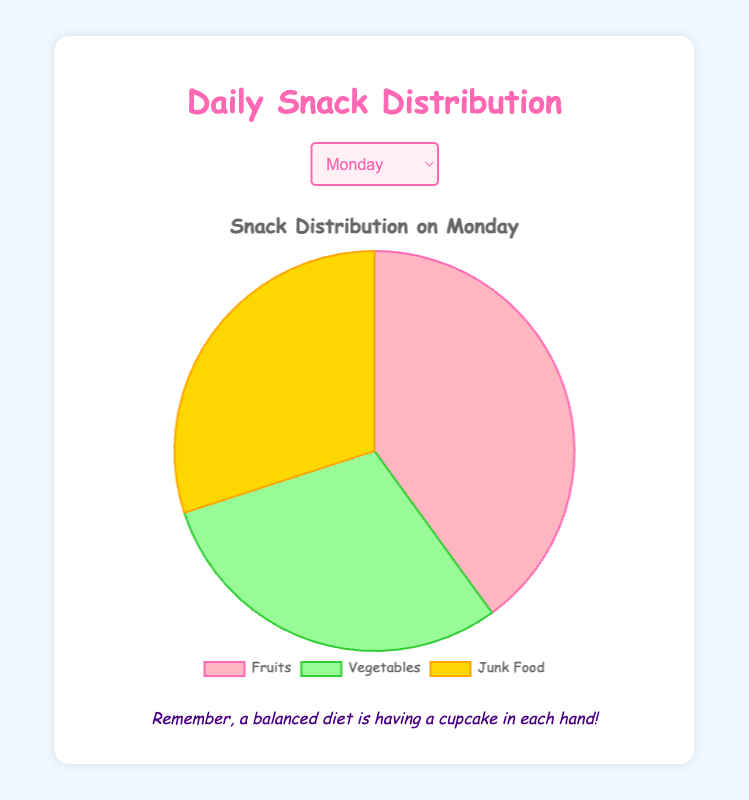Which day has the highest percentage of Fruits? To find the day with the highest percentage of Fruits, compare the values for each day. Friday has the highest percentage of Fruits at 50%.
Answer: Friday Which day has the lowest percentage of Vegetables? To determine the day with the lowest percentage of Vegetables, examine the percentage of Vegetables for each day. Sunday has the lowest percentage at 20%.
Answer: Sunday How does the percentage of Junk Food consumed on Saturday compare to Wednesday? Saturday has 50% Junk Food, while Wednesday has 20%. Subtract Wednesday's percentage from Saturday's. 50% - 20% = 30%.
Answer: 30% more on Saturday What is the average percentage of Fruits consumed from Monday to Wednesday? Sum the percentages of Fruits from Monday (40%), Tuesday (35%), and Wednesday (45%) and divide by 3. (40 + 35 + 45) / 3 = 120 / 3 = 40%.
Answer: 40% On which day is there an equal percentage of Vegetables and Junk Food? Check the percentages for Vegetables and Junk Food for each day. On Monday and Thursday, both are 30%.
Answer: Monday and Thursday Compare the consumption of Vegetables on Tuesday and Sunday. Which day has more, and by how much? Tuesday has 40% Vegetables, and Sunday has 20%. Subtract Sunday's percentage from Tuesday's. 40% - 20% = 20%.
Answer: 20% more on Tuesday What is the sum of the percentages of Fruits and Vegetables on Friday? Add the percentages of Fruits (50%) and Vegetables (30%) on Friday. 50% + 30% = 80%.
Answer: 80% Which day has the least percentage of Junk Food? Compare the percentage of Junk Food for each day. Wednesday and Friday have the lowest at 20%.
Answer: Wednesday and Friday 